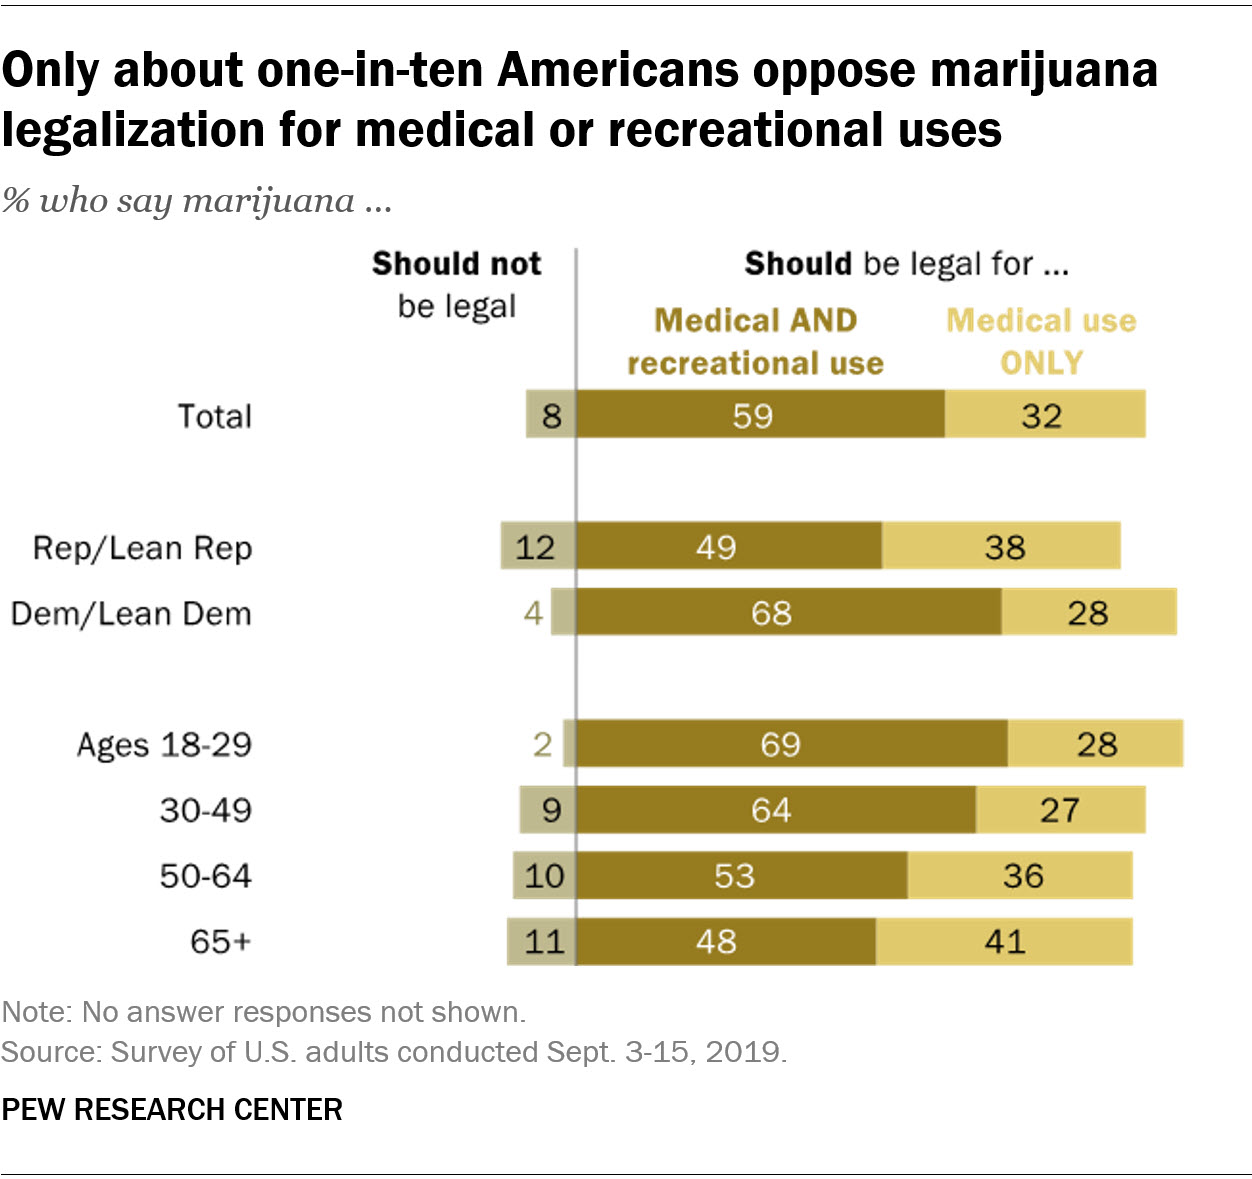Outline some significant characteristics in this image. According to a survey, 0.59% of Americans favor the legalization of marijuana for both medical and recreational use. According to the given ratio, 0.042361111... represents the average ratio of Americans who oppose the legalization of marijuana in the age group of 50-64 and 65+. 